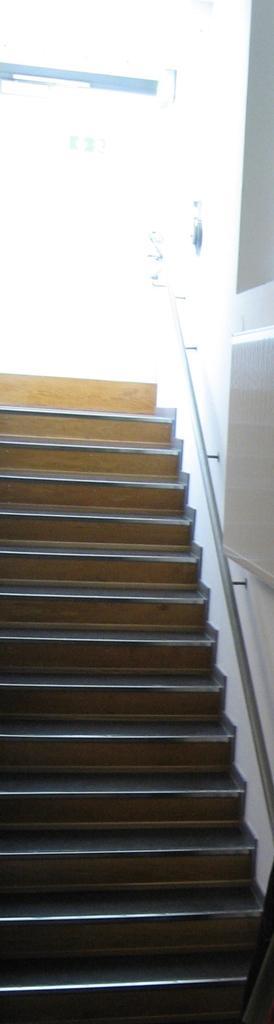How would you summarize this image in a sentence or two? In the picture I can see a staircase and some other objects. 